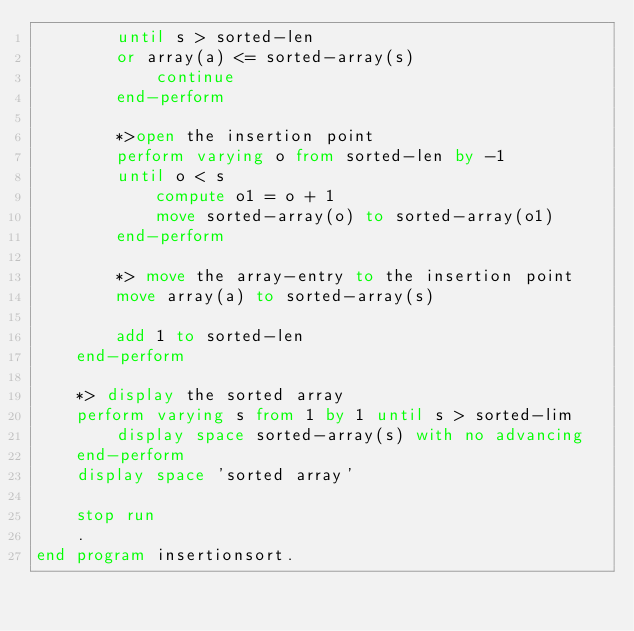Convert code to text. <code><loc_0><loc_0><loc_500><loc_500><_COBOL_>        until s > sorted-len
        or array(a) <= sorted-array(s)
            continue
        end-perform

        *>open the insertion point
        perform varying o from sorted-len by -1
        until o < s
            compute o1 = o + 1
            move sorted-array(o) to sorted-array(o1)
        end-perform

        *> move the array-entry to the insertion point
        move array(a) to sorted-array(s)

        add 1 to sorted-len
    end-perform

    *> display the sorted array
    perform varying s from 1 by 1 until s > sorted-lim
        display space sorted-array(s) with no advancing
    end-perform
    display space 'sorted array'

    stop run
    .
end program insertionsort.
</code> 